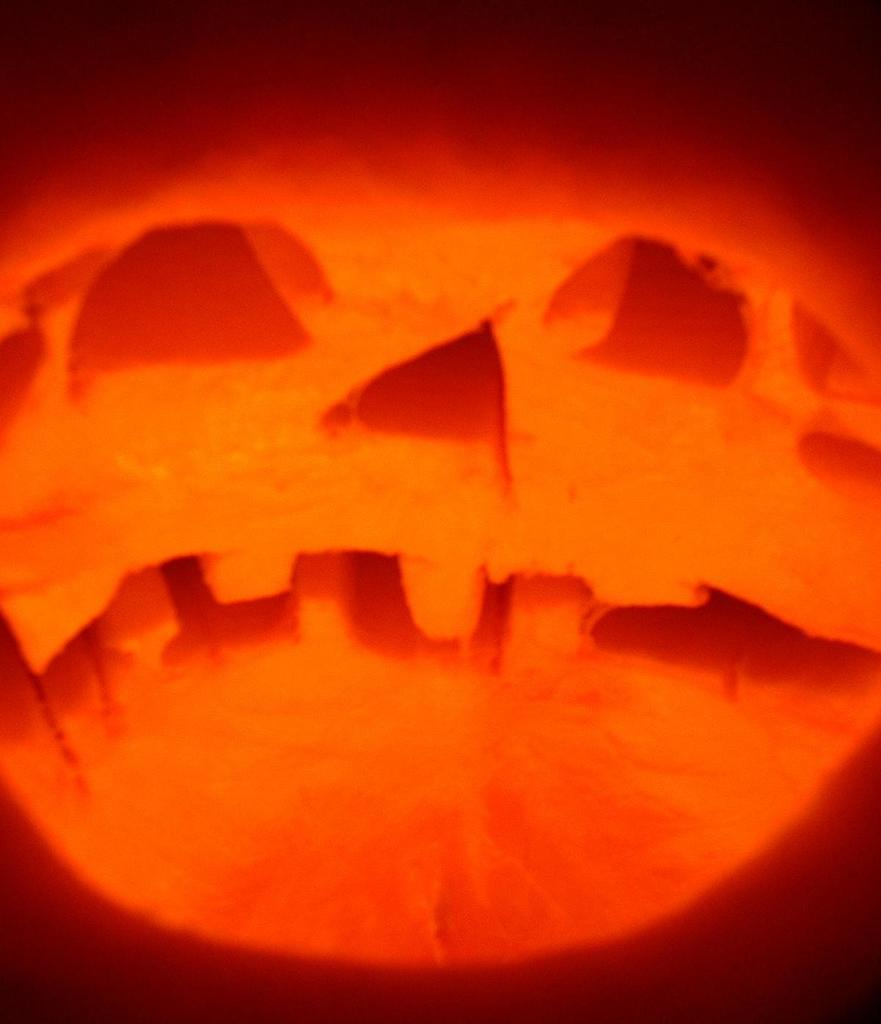What is the color of the object in the image? The object in the image is orange-colored. What type of committee is responsible for the decision-making process in the image? There is no committee or decision-making process present in the image; it only features an orange-colored object. 